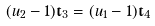Convert formula to latex. <formula><loc_0><loc_0><loc_500><loc_500>( u _ { 2 } - 1 ) \mathbf t _ { 3 } = ( u _ { 1 } - 1 ) \mathbf t _ { 4 }</formula> 